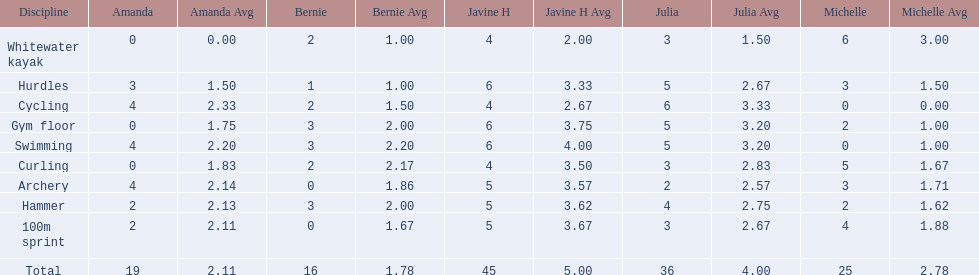Who is the faster runner? Javine H. 